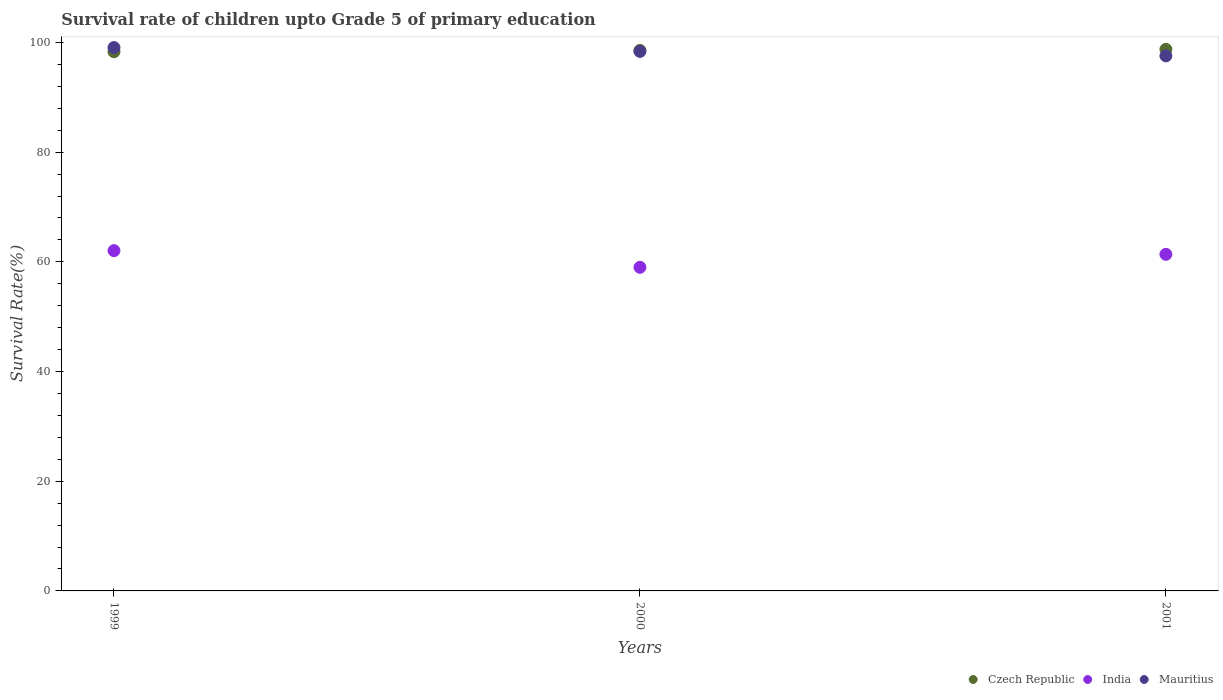How many different coloured dotlines are there?
Ensure brevity in your answer.  3. Is the number of dotlines equal to the number of legend labels?
Make the answer very short. Yes. What is the survival rate of children in India in 2001?
Keep it short and to the point. 61.37. Across all years, what is the maximum survival rate of children in Mauritius?
Your response must be concise. 99.08. Across all years, what is the minimum survival rate of children in India?
Give a very brief answer. 59.01. What is the total survival rate of children in India in the graph?
Provide a short and direct response. 182.43. What is the difference between the survival rate of children in Mauritius in 1999 and that in 2000?
Your answer should be very brief. 0.7. What is the difference between the survival rate of children in India in 2000 and the survival rate of children in Mauritius in 2001?
Offer a terse response. -38.56. What is the average survival rate of children in Mauritius per year?
Offer a terse response. 98.34. In the year 1999, what is the difference between the survival rate of children in Czech Republic and survival rate of children in India?
Keep it short and to the point. 36.27. In how many years, is the survival rate of children in Mauritius greater than 68 %?
Offer a very short reply. 3. What is the ratio of the survival rate of children in India in 1999 to that in 2001?
Your answer should be compact. 1.01. Is the survival rate of children in Mauritius in 2000 less than that in 2001?
Make the answer very short. No. Is the difference between the survival rate of children in Czech Republic in 1999 and 2000 greater than the difference between the survival rate of children in India in 1999 and 2000?
Provide a succinct answer. No. What is the difference between the highest and the second highest survival rate of children in Czech Republic?
Provide a succinct answer. 0.2. What is the difference between the highest and the lowest survival rate of children in India?
Your response must be concise. 3.04. Is the survival rate of children in Mauritius strictly greater than the survival rate of children in India over the years?
Offer a very short reply. Yes. Is the survival rate of children in Czech Republic strictly less than the survival rate of children in Mauritius over the years?
Offer a very short reply. No. How many years are there in the graph?
Your response must be concise. 3. Does the graph contain any zero values?
Provide a succinct answer. No. Where does the legend appear in the graph?
Offer a very short reply. Bottom right. How many legend labels are there?
Give a very brief answer. 3. How are the legend labels stacked?
Offer a terse response. Horizontal. What is the title of the graph?
Your answer should be compact. Survival rate of children upto Grade 5 of primary education. Does "Sudan" appear as one of the legend labels in the graph?
Your answer should be compact. No. What is the label or title of the Y-axis?
Your response must be concise. Survival Rate(%). What is the Survival Rate(%) in Czech Republic in 1999?
Offer a very short reply. 98.31. What is the Survival Rate(%) in India in 1999?
Offer a very short reply. 62.05. What is the Survival Rate(%) in Mauritius in 1999?
Ensure brevity in your answer.  99.08. What is the Survival Rate(%) in Czech Republic in 2000?
Your response must be concise. 98.55. What is the Survival Rate(%) in India in 2000?
Your answer should be compact. 59.01. What is the Survival Rate(%) in Mauritius in 2000?
Offer a very short reply. 98.38. What is the Survival Rate(%) of Czech Republic in 2001?
Provide a succinct answer. 98.75. What is the Survival Rate(%) of India in 2001?
Your answer should be very brief. 61.37. What is the Survival Rate(%) of Mauritius in 2001?
Ensure brevity in your answer.  97.56. Across all years, what is the maximum Survival Rate(%) in Czech Republic?
Provide a short and direct response. 98.75. Across all years, what is the maximum Survival Rate(%) in India?
Keep it short and to the point. 62.05. Across all years, what is the maximum Survival Rate(%) of Mauritius?
Offer a very short reply. 99.08. Across all years, what is the minimum Survival Rate(%) in Czech Republic?
Keep it short and to the point. 98.31. Across all years, what is the minimum Survival Rate(%) in India?
Keep it short and to the point. 59.01. Across all years, what is the minimum Survival Rate(%) of Mauritius?
Make the answer very short. 97.56. What is the total Survival Rate(%) in Czech Republic in the graph?
Offer a terse response. 295.61. What is the total Survival Rate(%) in India in the graph?
Your response must be concise. 182.43. What is the total Survival Rate(%) of Mauritius in the graph?
Provide a short and direct response. 295.01. What is the difference between the Survival Rate(%) of Czech Republic in 1999 and that in 2000?
Make the answer very short. -0.24. What is the difference between the Survival Rate(%) of India in 1999 and that in 2000?
Offer a very short reply. 3.04. What is the difference between the Survival Rate(%) in Mauritius in 1999 and that in 2000?
Offer a terse response. 0.7. What is the difference between the Survival Rate(%) in Czech Republic in 1999 and that in 2001?
Make the answer very short. -0.44. What is the difference between the Survival Rate(%) in India in 1999 and that in 2001?
Your response must be concise. 0.67. What is the difference between the Survival Rate(%) in Mauritius in 1999 and that in 2001?
Provide a succinct answer. 1.51. What is the difference between the Survival Rate(%) of Czech Republic in 2000 and that in 2001?
Provide a succinct answer. -0.2. What is the difference between the Survival Rate(%) in India in 2000 and that in 2001?
Provide a succinct answer. -2.37. What is the difference between the Survival Rate(%) in Mauritius in 2000 and that in 2001?
Give a very brief answer. 0.81. What is the difference between the Survival Rate(%) of Czech Republic in 1999 and the Survival Rate(%) of India in 2000?
Your response must be concise. 39.31. What is the difference between the Survival Rate(%) in Czech Republic in 1999 and the Survival Rate(%) in Mauritius in 2000?
Your answer should be very brief. -0.06. What is the difference between the Survival Rate(%) in India in 1999 and the Survival Rate(%) in Mauritius in 2000?
Your answer should be very brief. -36.33. What is the difference between the Survival Rate(%) in Czech Republic in 1999 and the Survival Rate(%) in India in 2001?
Keep it short and to the point. 36.94. What is the difference between the Survival Rate(%) of Czech Republic in 1999 and the Survival Rate(%) of Mauritius in 2001?
Your answer should be compact. 0.75. What is the difference between the Survival Rate(%) in India in 1999 and the Survival Rate(%) in Mauritius in 2001?
Give a very brief answer. -35.51. What is the difference between the Survival Rate(%) in Czech Republic in 2000 and the Survival Rate(%) in India in 2001?
Your answer should be very brief. 37.18. What is the difference between the Survival Rate(%) in Czech Republic in 2000 and the Survival Rate(%) in Mauritius in 2001?
Provide a short and direct response. 0.99. What is the difference between the Survival Rate(%) of India in 2000 and the Survival Rate(%) of Mauritius in 2001?
Provide a succinct answer. -38.56. What is the average Survival Rate(%) of Czech Republic per year?
Your answer should be very brief. 98.54. What is the average Survival Rate(%) in India per year?
Give a very brief answer. 60.81. What is the average Survival Rate(%) of Mauritius per year?
Your answer should be compact. 98.34. In the year 1999, what is the difference between the Survival Rate(%) in Czech Republic and Survival Rate(%) in India?
Provide a short and direct response. 36.27. In the year 1999, what is the difference between the Survival Rate(%) in Czech Republic and Survival Rate(%) in Mauritius?
Give a very brief answer. -0.76. In the year 1999, what is the difference between the Survival Rate(%) of India and Survival Rate(%) of Mauritius?
Your response must be concise. -37.03. In the year 2000, what is the difference between the Survival Rate(%) of Czech Republic and Survival Rate(%) of India?
Make the answer very short. 39.54. In the year 2000, what is the difference between the Survival Rate(%) in Czech Republic and Survival Rate(%) in Mauritius?
Keep it short and to the point. 0.17. In the year 2000, what is the difference between the Survival Rate(%) in India and Survival Rate(%) in Mauritius?
Make the answer very short. -39.37. In the year 2001, what is the difference between the Survival Rate(%) in Czech Republic and Survival Rate(%) in India?
Ensure brevity in your answer.  37.38. In the year 2001, what is the difference between the Survival Rate(%) in Czech Republic and Survival Rate(%) in Mauritius?
Give a very brief answer. 1.19. In the year 2001, what is the difference between the Survival Rate(%) in India and Survival Rate(%) in Mauritius?
Ensure brevity in your answer.  -36.19. What is the ratio of the Survival Rate(%) of Czech Republic in 1999 to that in 2000?
Offer a terse response. 1. What is the ratio of the Survival Rate(%) in India in 1999 to that in 2000?
Make the answer very short. 1.05. What is the ratio of the Survival Rate(%) in Mauritius in 1999 to that in 2000?
Provide a short and direct response. 1.01. What is the ratio of the Survival Rate(%) of Czech Republic in 1999 to that in 2001?
Provide a short and direct response. 1. What is the ratio of the Survival Rate(%) of India in 1999 to that in 2001?
Offer a terse response. 1.01. What is the ratio of the Survival Rate(%) in Mauritius in 1999 to that in 2001?
Keep it short and to the point. 1.02. What is the ratio of the Survival Rate(%) in Czech Republic in 2000 to that in 2001?
Offer a terse response. 1. What is the ratio of the Survival Rate(%) of India in 2000 to that in 2001?
Your response must be concise. 0.96. What is the ratio of the Survival Rate(%) in Mauritius in 2000 to that in 2001?
Your answer should be very brief. 1.01. What is the difference between the highest and the second highest Survival Rate(%) in Czech Republic?
Keep it short and to the point. 0.2. What is the difference between the highest and the second highest Survival Rate(%) of India?
Provide a succinct answer. 0.67. What is the difference between the highest and the second highest Survival Rate(%) of Mauritius?
Make the answer very short. 0.7. What is the difference between the highest and the lowest Survival Rate(%) of Czech Republic?
Your answer should be very brief. 0.44. What is the difference between the highest and the lowest Survival Rate(%) of India?
Keep it short and to the point. 3.04. What is the difference between the highest and the lowest Survival Rate(%) of Mauritius?
Offer a very short reply. 1.51. 